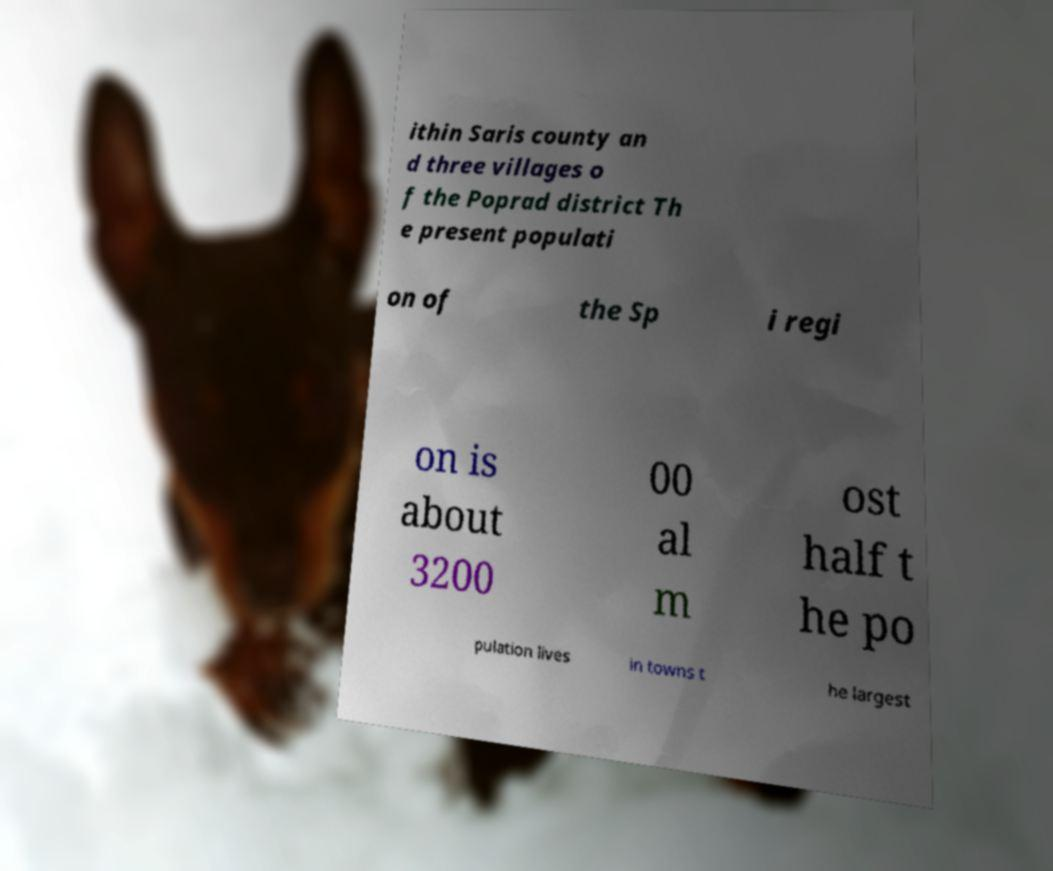Could you extract and type out the text from this image? ithin Saris county an d three villages o f the Poprad district Th e present populati on of the Sp i regi on is about 3200 00 al m ost half t he po pulation lives in towns t he largest 